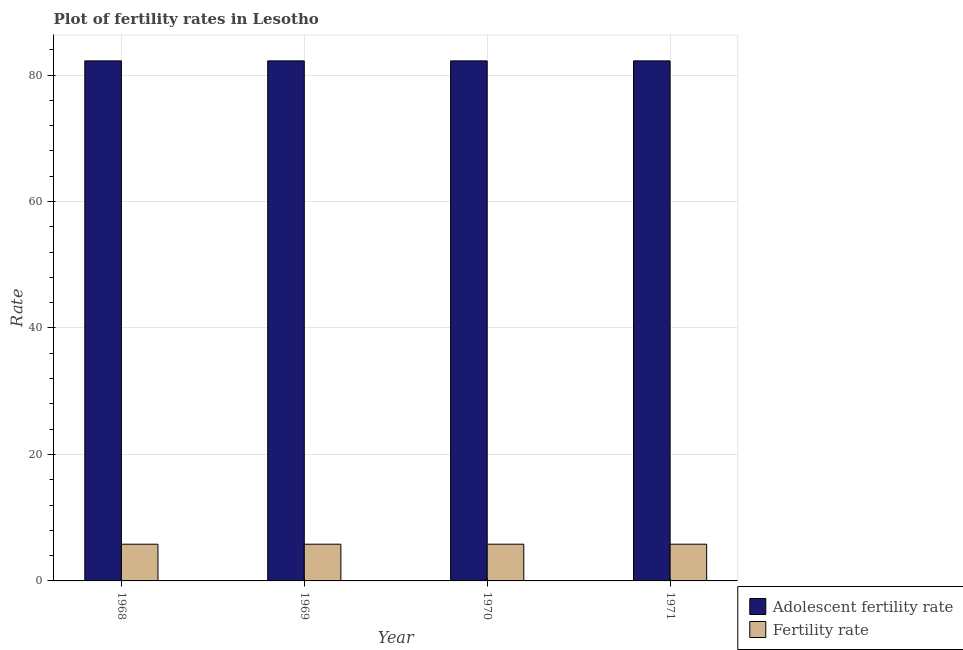How many groups of bars are there?
Your answer should be very brief. 4. Are the number of bars per tick equal to the number of legend labels?
Make the answer very short. Yes. Are the number of bars on each tick of the X-axis equal?
Ensure brevity in your answer.  Yes. How many bars are there on the 4th tick from the left?
Your answer should be very brief. 2. How many bars are there on the 2nd tick from the right?
Keep it short and to the point. 2. What is the label of the 2nd group of bars from the left?
Provide a succinct answer. 1969. In how many cases, is the number of bars for a given year not equal to the number of legend labels?
Offer a very short reply. 0. What is the adolescent fertility rate in 1968?
Give a very brief answer. 82.24. Across all years, what is the maximum adolescent fertility rate?
Your response must be concise. 82.24. Across all years, what is the minimum fertility rate?
Your answer should be compact. 5.8. In which year was the adolescent fertility rate minimum?
Your answer should be very brief. 1968. What is the total fertility rate in the graph?
Offer a very short reply. 23.23. What is the average fertility rate per year?
Provide a succinct answer. 5.81. Is the difference between the adolescent fertility rate in 1969 and 1970 greater than the difference between the fertility rate in 1969 and 1970?
Ensure brevity in your answer.  No. What is the difference between the highest and the second highest fertility rate?
Provide a short and direct response. 0. What does the 2nd bar from the left in 1971 represents?
Your answer should be compact. Fertility rate. What does the 1st bar from the right in 1971 represents?
Provide a short and direct response. Fertility rate. How many bars are there?
Your answer should be compact. 8. Are the values on the major ticks of Y-axis written in scientific E-notation?
Your response must be concise. No. Does the graph contain any zero values?
Offer a terse response. No. Where does the legend appear in the graph?
Your answer should be compact. Bottom right. How many legend labels are there?
Make the answer very short. 2. How are the legend labels stacked?
Offer a terse response. Vertical. What is the title of the graph?
Keep it short and to the point. Plot of fertility rates in Lesotho. Does "Urban" appear as one of the legend labels in the graph?
Provide a short and direct response. No. What is the label or title of the Y-axis?
Give a very brief answer. Rate. What is the Rate of Adolescent fertility rate in 1968?
Offer a very short reply. 82.24. What is the Rate in Fertility rate in 1968?
Your answer should be very brief. 5.8. What is the Rate in Adolescent fertility rate in 1969?
Provide a short and direct response. 82.24. What is the Rate in Fertility rate in 1969?
Ensure brevity in your answer.  5.81. What is the Rate in Adolescent fertility rate in 1970?
Offer a terse response. 82.24. What is the Rate in Fertility rate in 1970?
Provide a succinct answer. 5.81. What is the Rate in Adolescent fertility rate in 1971?
Ensure brevity in your answer.  82.24. What is the Rate in Fertility rate in 1971?
Make the answer very short. 5.81. Across all years, what is the maximum Rate in Adolescent fertility rate?
Make the answer very short. 82.24. Across all years, what is the maximum Rate in Fertility rate?
Offer a very short reply. 5.81. Across all years, what is the minimum Rate of Adolescent fertility rate?
Offer a terse response. 82.24. Across all years, what is the minimum Rate of Fertility rate?
Make the answer very short. 5.8. What is the total Rate of Adolescent fertility rate in the graph?
Your response must be concise. 328.98. What is the total Rate of Fertility rate in the graph?
Offer a very short reply. 23.23. What is the difference between the Rate of Fertility rate in 1968 and that in 1969?
Ensure brevity in your answer.  -0. What is the difference between the Rate in Adolescent fertility rate in 1968 and that in 1970?
Provide a succinct answer. 0. What is the difference between the Rate of Fertility rate in 1968 and that in 1970?
Your answer should be very brief. -0. What is the difference between the Rate of Adolescent fertility rate in 1968 and that in 1971?
Offer a very short reply. 0. What is the difference between the Rate in Fertility rate in 1968 and that in 1971?
Provide a succinct answer. -0. What is the difference between the Rate in Adolescent fertility rate in 1969 and that in 1970?
Provide a succinct answer. 0. What is the difference between the Rate of Fertility rate in 1969 and that in 1970?
Provide a short and direct response. -0. What is the difference between the Rate in Adolescent fertility rate in 1969 and that in 1971?
Give a very brief answer. 0. What is the difference between the Rate of Adolescent fertility rate in 1970 and that in 1971?
Your answer should be compact. 0. What is the difference between the Rate of Fertility rate in 1970 and that in 1971?
Your answer should be compact. 0. What is the difference between the Rate of Adolescent fertility rate in 1968 and the Rate of Fertility rate in 1969?
Offer a very short reply. 76.44. What is the difference between the Rate in Adolescent fertility rate in 1968 and the Rate in Fertility rate in 1970?
Provide a short and direct response. 76.44. What is the difference between the Rate of Adolescent fertility rate in 1968 and the Rate of Fertility rate in 1971?
Your response must be concise. 76.44. What is the difference between the Rate in Adolescent fertility rate in 1969 and the Rate in Fertility rate in 1970?
Your response must be concise. 76.44. What is the difference between the Rate in Adolescent fertility rate in 1969 and the Rate in Fertility rate in 1971?
Offer a terse response. 76.44. What is the difference between the Rate of Adolescent fertility rate in 1970 and the Rate of Fertility rate in 1971?
Provide a short and direct response. 76.44. What is the average Rate in Adolescent fertility rate per year?
Ensure brevity in your answer.  82.24. What is the average Rate of Fertility rate per year?
Your response must be concise. 5.81. In the year 1968, what is the difference between the Rate in Adolescent fertility rate and Rate in Fertility rate?
Your response must be concise. 76.44. In the year 1969, what is the difference between the Rate in Adolescent fertility rate and Rate in Fertility rate?
Provide a succinct answer. 76.44. In the year 1970, what is the difference between the Rate in Adolescent fertility rate and Rate in Fertility rate?
Your answer should be compact. 76.44. In the year 1971, what is the difference between the Rate of Adolescent fertility rate and Rate of Fertility rate?
Your answer should be very brief. 76.44. What is the ratio of the Rate in Adolescent fertility rate in 1968 to that in 1969?
Your response must be concise. 1. What is the ratio of the Rate in Fertility rate in 1968 to that in 1969?
Provide a short and direct response. 1. What is the ratio of the Rate in Fertility rate in 1968 to that in 1970?
Your answer should be very brief. 1. What is the ratio of the Rate in Adolescent fertility rate in 1969 to that in 1970?
Offer a terse response. 1. What is the ratio of the Rate of Adolescent fertility rate in 1970 to that in 1971?
Offer a very short reply. 1. What is the difference between the highest and the lowest Rate of Adolescent fertility rate?
Ensure brevity in your answer.  0. What is the difference between the highest and the lowest Rate in Fertility rate?
Provide a succinct answer. 0. 